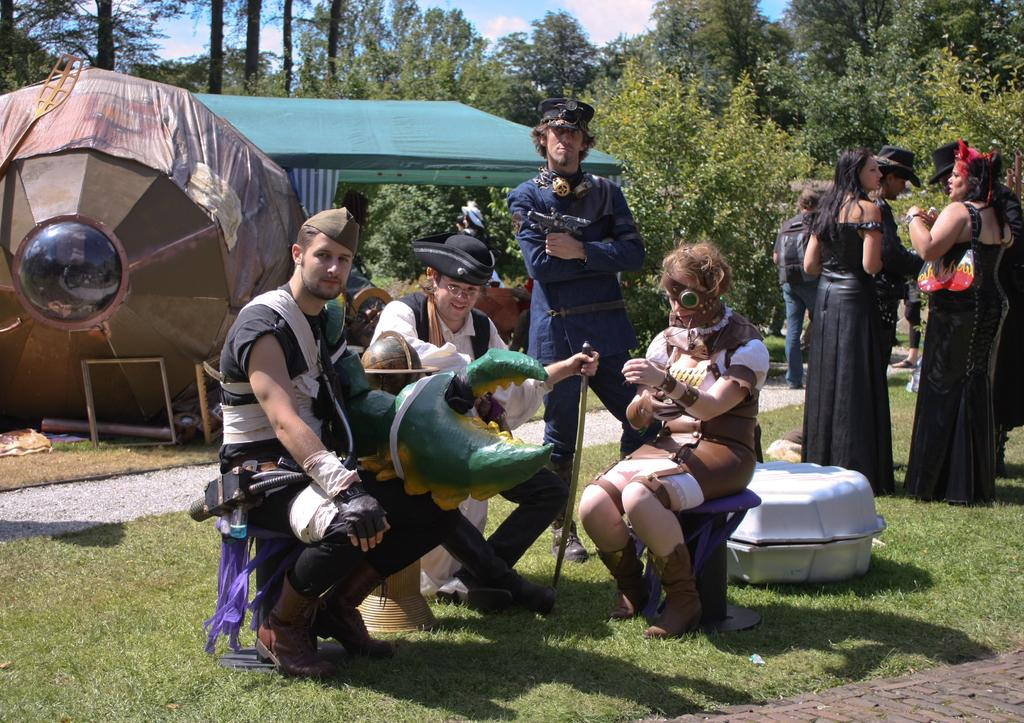How many people are sitting on chairs in the image? There are three persons sitting on chairs in the image. What is the ground surface like in the image? The ground is covered with grass. What can be seen in the background of the image? There are people, a tent, trees, and the sky visible in the background of the image. What type of pollution can be seen in the image? There is no pollution visible in the image. How are the people in the background of the image connected to the persons sitting on chairs? The provided facts do not give any information about a connection between the people in the background and the persons sitting on chairs. 